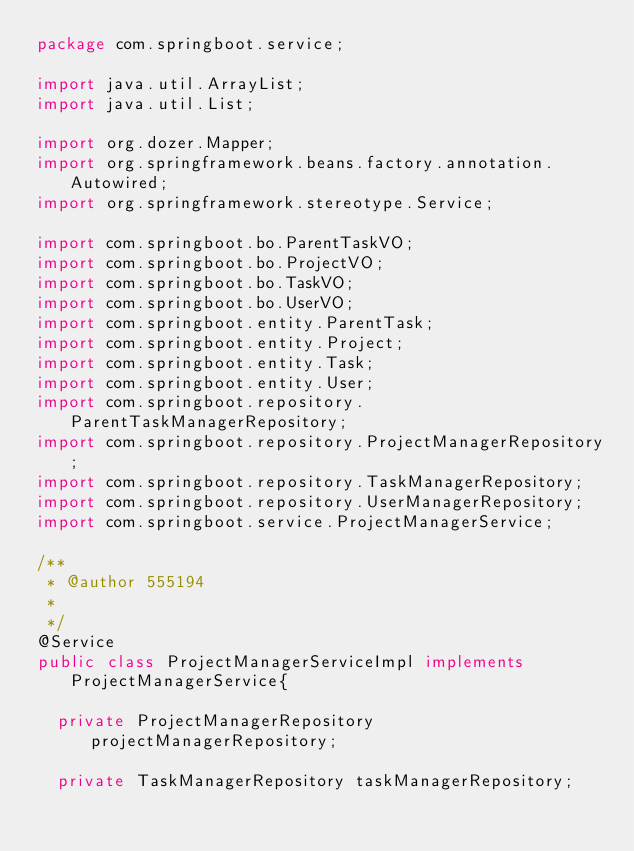Convert code to text. <code><loc_0><loc_0><loc_500><loc_500><_Java_>package com.springboot.service;

import java.util.ArrayList;
import java.util.List;

import org.dozer.Mapper;
import org.springframework.beans.factory.annotation.Autowired;
import org.springframework.stereotype.Service;

import com.springboot.bo.ParentTaskVO;
import com.springboot.bo.ProjectVO;
import com.springboot.bo.TaskVO;
import com.springboot.bo.UserVO;
import com.springboot.entity.ParentTask;
import com.springboot.entity.Project;
import com.springboot.entity.Task;
import com.springboot.entity.User;
import com.springboot.repository.ParentTaskManagerRepository;
import com.springboot.repository.ProjectManagerRepository;
import com.springboot.repository.TaskManagerRepository;
import com.springboot.repository.UserManagerRepository;
import com.springboot.service.ProjectManagerService;

/**
 * @author 555194
 *
 */
@Service
public class ProjectManagerServiceImpl implements ProjectManagerService{

	private ProjectManagerRepository projectManagerRepository;
	
	private TaskManagerRepository taskManagerRepository;
	</code> 